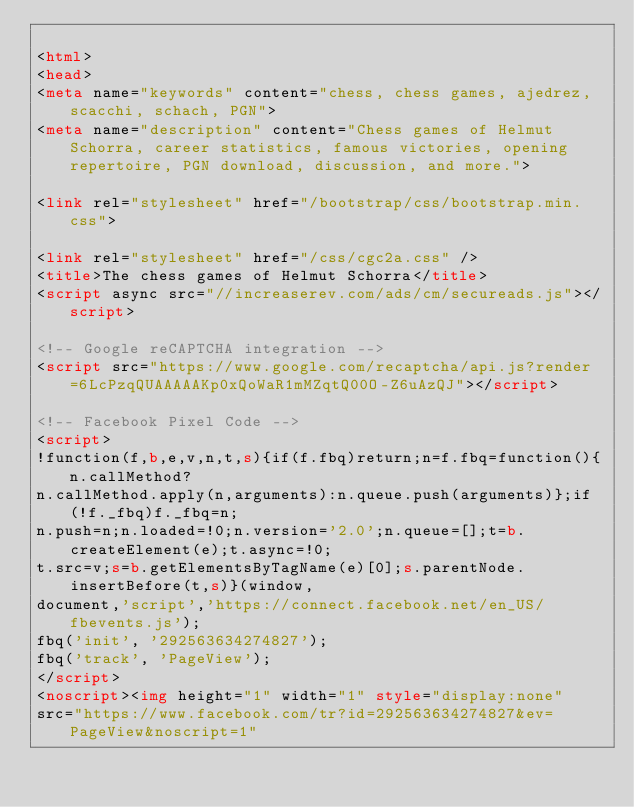<code> <loc_0><loc_0><loc_500><loc_500><_HTML_>
<html>
<head>
<meta name="keywords" content="chess, chess games, ajedrez, scacchi, schach, PGN">
<meta name="description" content="Chess games of Helmut Schorra, career statistics, famous victories, opening repertoire, PGN download, discussion, and more.">

<link rel="stylesheet" href="/bootstrap/css/bootstrap.min.css">

<link rel="stylesheet" href="/css/cgc2a.css" />
<title>The chess games of Helmut Schorra</title>
<script async src="//increaserev.com/ads/cm/secureads.js"></script>

<!-- Google reCAPTCHA integration -->
<script src="https://www.google.com/recaptcha/api.js?render=6LcPzqQUAAAAAKp0xQoWaR1mMZqtQ00O-Z6uAzQJ"></script>

<!-- Facebook Pixel Code -->
<script>
!function(f,b,e,v,n,t,s){if(f.fbq)return;n=f.fbq=function(){n.callMethod?
n.callMethod.apply(n,arguments):n.queue.push(arguments)};if(!f._fbq)f._fbq=n;
n.push=n;n.loaded=!0;n.version='2.0';n.queue=[];t=b.createElement(e);t.async=!0;
t.src=v;s=b.getElementsByTagName(e)[0];s.parentNode.insertBefore(t,s)}(window,
document,'script','https://connect.facebook.net/en_US/fbevents.js');
fbq('init', '292563634274827');
fbq('track', 'PageView');
</script>
<noscript><img height="1" width="1" style="display:none"
src="https://www.facebook.com/tr?id=292563634274827&ev=PageView&noscript=1"</code> 